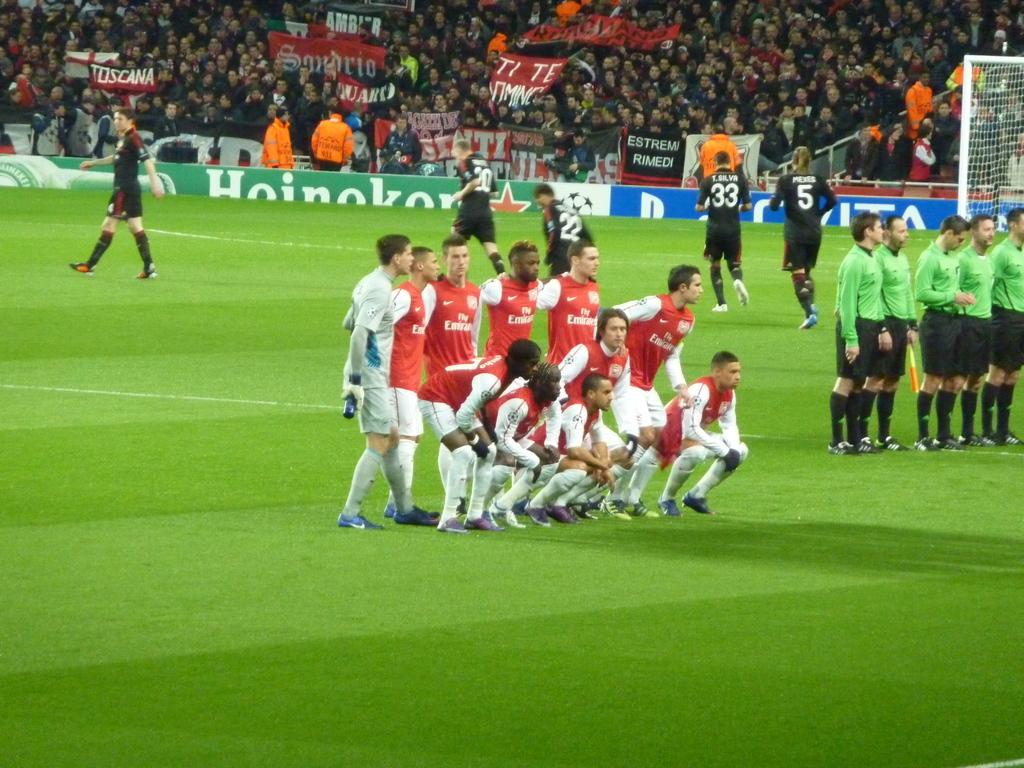<image>
Summarize the visual content of the image. A group of soccer players wearing red and white uniforms with "Fly Emirates" written on the shirt are posing for a picture. 